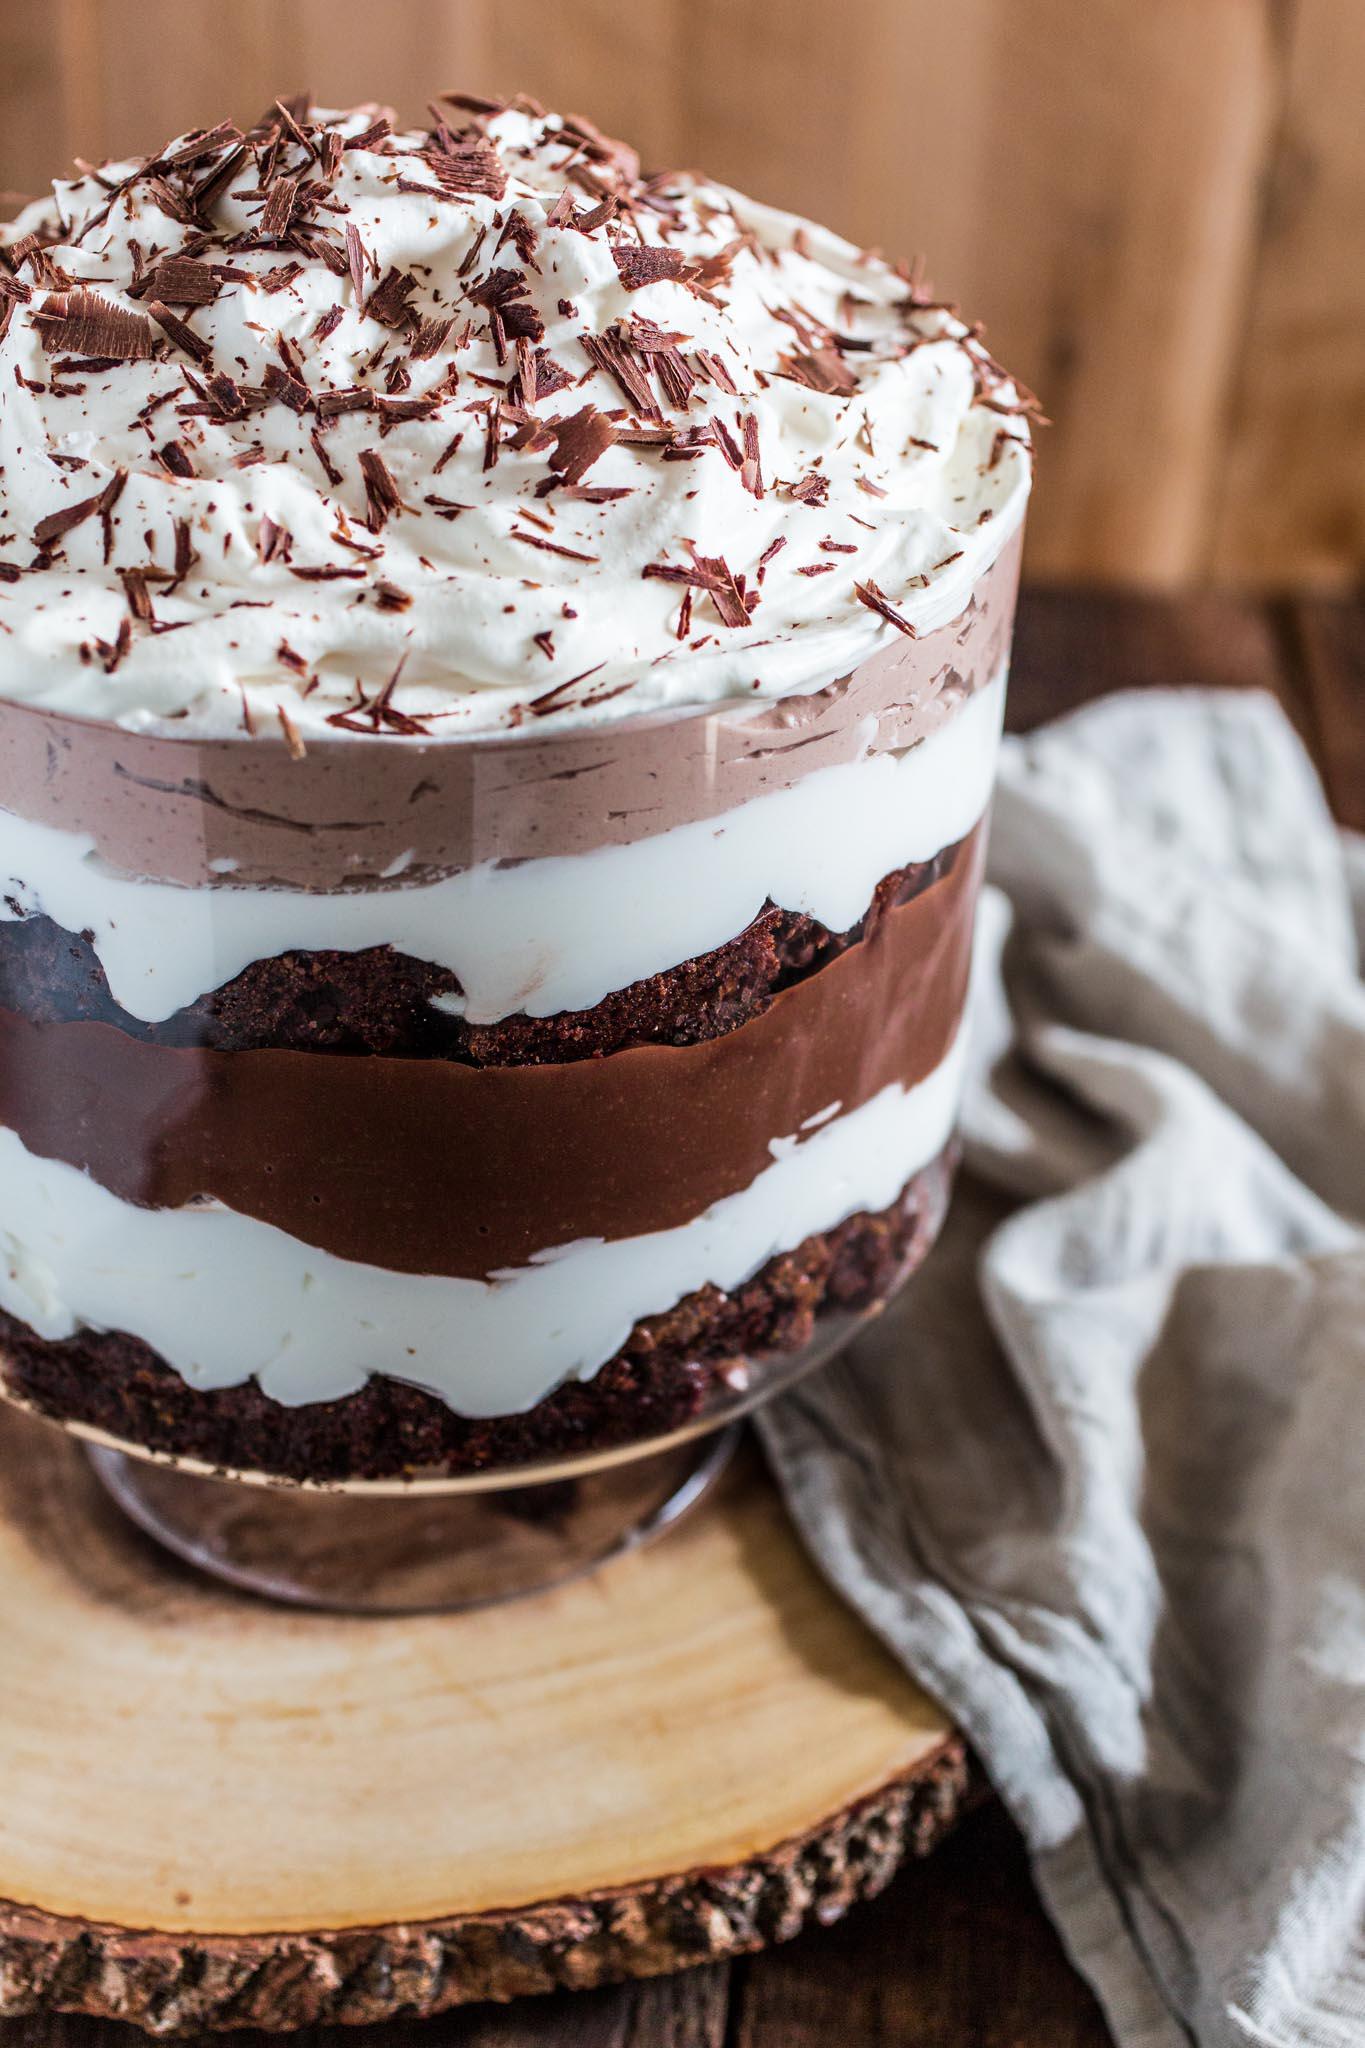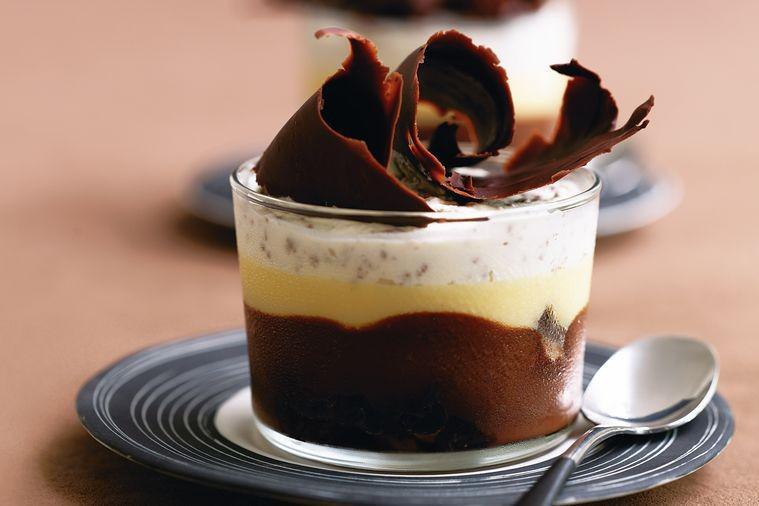The first image is the image on the left, the second image is the image on the right. Assess this claim about the two images: "Two large layered desserts made with chocolate and creamy layers and topped with a garnish are in clear glass bowls, at least one of them footed.". Correct or not? Answer yes or no. No. The first image is the image on the left, the second image is the image on the right. For the images shown, is this caption "A dessert with a thick bottom chocolate layer and chocolate garnish on top is served in a non-footed glass." true? Answer yes or no. Yes. 